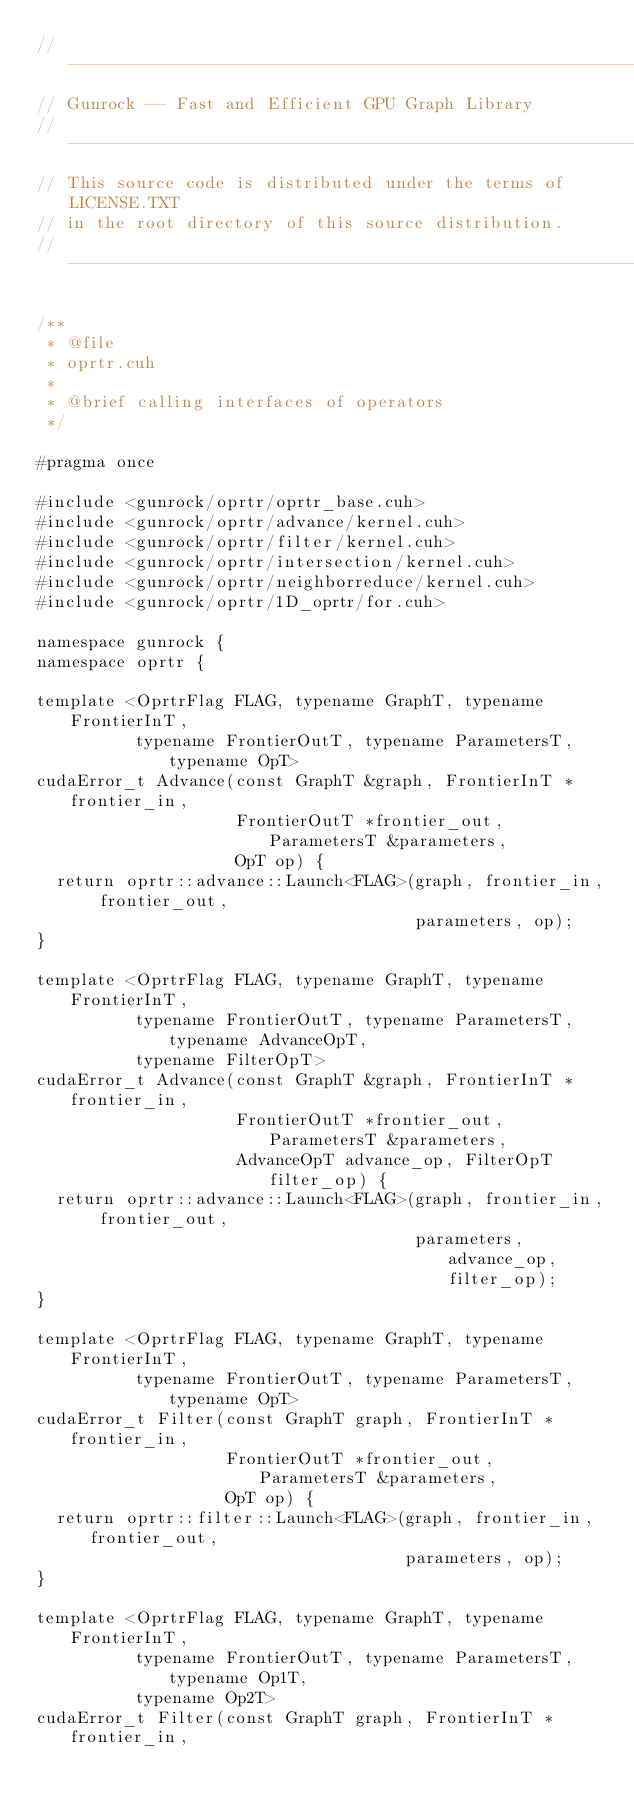Convert code to text. <code><loc_0><loc_0><loc_500><loc_500><_Cuda_>// ----------------------------------------------------------------
// Gunrock -- Fast and Efficient GPU Graph Library
// ----------------------------------------------------------------
// This source code is distributed under the terms of LICENSE.TXT
// in the root directory of this source distribution.
// ----------------------------------------------------------------

/**
 * @file
 * oprtr.cuh
 *
 * @brief calling interfaces of operators
 */

#pragma once

#include <gunrock/oprtr/oprtr_base.cuh>
#include <gunrock/oprtr/advance/kernel.cuh>
#include <gunrock/oprtr/filter/kernel.cuh>
#include <gunrock/oprtr/intersection/kernel.cuh>
#include <gunrock/oprtr/neighborreduce/kernel.cuh>
#include <gunrock/oprtr/1D_oprtr/for.cuh>

namespace gunrock {
namespace oprtr {

template <OprtrFlag FLAG, typename GraphT, typename FrontierInT,
          typename FrontierOutT, typename ParametersT, typename OpT>
cudaError_t Advance(const GraphT &graph, FrontierInT *frontier_in,
                    FrontierOutT *frontier_out, ParametersT &parameters,
                    OpT op) {
  return oprtr::advance::Launch<FLAG>(graph, frontier_in, frontier_out,
                                      parameters, op);
}

template <OprtrFlag FLAG, typename GraphT, typename FrontierInT,
          typename FrontierOutT, typename ParametersT, typename AdvanceOpT,
          typename FilterOpT>
cudaError_t Advance(const GraphT &graph, FrontierInT *frontier_in,
                    FrontierOutT *frontier_out, ParametersT &parameters,
                    AdvanceOpT advance_op, FilterOpT filter_op) {
  return oprtr::advance::Launch<FLAG>(graph, frontier_in, frontier_out,
                                      parameters, advance_op, filter_op);
}

template <OprtrFlag FLAG, typename GraphT, typename FrontierInT,
          typename FrontierOutT, typename ParametersT, typename OpT>
cudaError_t Filter(const GraphT graph, FrontierInT *frontier_in,
                   FrontierOutT *frontier_out, ParametersT &parameters,
                   OpT op) {
  return oprtr::filter::Launch<FLAG>(graph, frontier_in, frontier_out,
                                     parameters, op);
}

template <OprtrFlag FLAG, typename GraphT, typename FrontierInT,
          typename FrontierOutT, typename ParametersT, typename Op1T,
          typename Op2T>
cudaError_t Filter(const GraphT graph, FrontierInT *frontier_in,</code> 